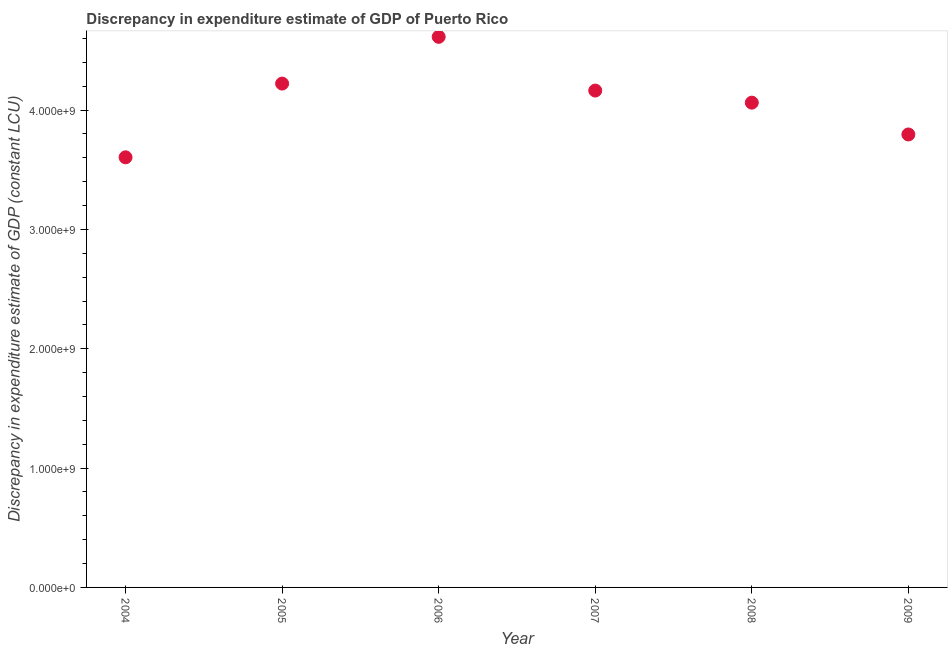What is the discrepancy in expenditure estimate of gdp in 2005?
Ensure brevity in your answer.  4.22e+09. Across all years, what is the maximum discrepancy in expenditure estimate of gdp?
Offer a terse response. 4.61e+09. Across all years, what is the minimum discrepancy in expenditure estimate of gdp?
Offer a terse response. 3.60e+09. In which year was the discrepancy in expenditure estimate of gdp minimum?
Provide a succinct answer. 2004. What is the sum of the discrepancy in expenditure estimate of gdp?
Your response must be concise. 2.45e+1. What is the difference between the discrepancy in expenditure estimate of gdp in 2005 and 2007?
Your response must be concise. 5.86e+07. What is the average discrepancy in expenditure estimate of gdp per year?
Provide a succinct answer. 4.08e+09. What is the median discrepancy in expenditure estimate of gdp?
Provide a succinct answer. 4.11e+09. Do a majority of the years between 2005 and 2009 (inclusive) have discrepancy in expenditure estimate of gdp greater than 400000000 LCU?
Offer a terse response. Yes. What is the ratio of the discrepancy in expenditure estimate of gdp in 2006 to that in 2007?
Provide a short and direct response. 1.11. Is the discrepancy in expenditure estimate of gdp in 2005 less than that in 2007?
Provide a short and direct response. No. Is the difference between the discrepancy in expenditure estimate of gdp in 2004 and 2006 greater than the difference between any two years?
Provide a short and direct response. Yes. What is the difference between the highest and the second highest discrepancy in expenditure estimate of gdp?
Your answer should be compact. 3.92e+08. What is the difference between the highest and the lowest discrepancy in expenditure estimate of gdp?
Your response must be concise. 1.01e+09. In how many years, is the discrepancy in expenditure estimate of gdp greater than the average discrepancy in expenditure estimate of gdp taken over all years?
Provide a succinct answer. 3. How many dotlines are there?
Keep it short and to the point. 1. How many years are there in the graph?
Keep it short and to the point. 6. Are the values on the major ticks of Y-axis written in scientific E-notation?
Ensure brevity in your answer.  Yes. Does the graph contain any zero values?
Your response must be concise. No. What is the title of the graph?
Provide a succinct answer. Discrepancy in expenditure estimate of GDP of Puerto Rico. What is the label or title of the Y-axis?
Your answer should be very brief. Discrepancy in expenditure estimate of GDP (constant LCU). What is the Discrepancy in expenditure estimate of GDP (constant LCU) in 2004?
Provide a succinct answer. 3.60e+09. What is the Discrepancy in expenditure estimate of GDP (constant LCU) in 2005?
Ensure brevity in your answer.  4.22e+09. What is the Discrepancy in expenditure estimate of GDP (constant LCU) in 2006?
Your answer should be compact. 4.61e+09. What is the Discrepancy in expenditure estimate of GDP (constant LCU) in 2007?
Keep it short and to the point. 4.16e+09. What is the Discrepancy in expenditure estimate of GDP (constant LCU) in 2008?
Provide a succinct answer. 4.06e+09. What is the Discrepancy in expenditure estimate of GDP (constant LCU) in 2009?
Provide a short and direct response. 3.80e+09. What is the difference between the Discrepancy in expenditure estimate of GDP (constant LCU) in 2004 and 2005?
Provide a succinct answer. -6.18e+08. What is the difference between the Discrepancy in expenditure estimate of GDP (constant LCU) in 2004 and 2006?
Your answer should be very brief. -1.01e+09. What is the difference between the Discrepancy in expenditure estimate of GDP (constant LCU) in 2004 and 2007?
Your response must be concise. -5.59e+08. What is the difference between the Discrepancy in expenditure estimate of GDP (constant LCU) in 2004 and 2008?
Provide a short and direct response. -4.58e+08. What is the difference between the Discrepancy in expenditure estimate of GDP (constant LCU) in 2004 and 2009?
Offer a terse response. -1.91e+08. What is the difference between the Discrepancy in expenditure estimate of GDP (constant LCU) in 2005 and 2006?
Offer a very short reply. -3.92e+08. What is the difference between the Discrepancy in expenditure estimate of GDP (constant LCU) in 2005 and 2007?
Provide a short and direct response. 5.86e+07. What is the difference between the Discrepancy in expenditure estimate of GDP (constant LCU) in 2005 and 2008?
Provide a short and direct response. 1.60e+08. What is the difference between the Discrepancy in expenditure estimate of GDP (constant LCU) in 2005 and 2009?
Your answer should be very brief. 4.26e+08. What is the difference between the Discrepancy in expenditure estimate of GDP (constant LCU) in 2006 and 2007?
Provide a short and direct response. 4.50e+08. What is the difference between the Discrepancy in expenditure estimate of GDP (constant LCU) in 2006 and 2008?
Your response must be concise. 5.51e+08. What is the difference between the Discrepancy in expenditure estimate of GDP (constant LCU) in 2006 and 2009?
Provide a succinct answer. 8.18e+08. What is the difference between the Discrepancy in expenditure estimate of GDP (constant LCU) in 2007 and 2008?
Ensure brevity in your answer.  1.01e+08. What is the difference between the Discrepancy in expenditure estimate of GDP (constant LCU) in 2007 and 2009?
Give a very brief answer. 3.68e+08. What is the difference between the Discrepancy in expenditure estimate of GDP (constant LCU) in 2008 and 2009?
Your response must be concise. 2.67e+08. What is the ratio of the Discrepancy in expenditure estimate of GDP (constant LCU) in 2004 to that in 2005?
Provide a succinct answer. 0.85. What is the ratio of the Discrepancy in expenditure estimate of GDP (constant LCU) in 2004 to that in 2006?
Provide a succinct answer. 0.78. What is the ratio of the Discrepancy in expenditure estimate of GDP (constant LCU) in 2004 to that in 2007?
Offer a terse response. 0.87. What is the ratio of the Discrepancy in expenditure estimate of GDP (constant LCU) in 2004 to that in 2008?
Your answer should be compact. 0.89. What is the ratio of the Discrepancy in expenditure estimate of GDP (constant LCU) in 2005 to that in 2006?
Offer a terse response. 0.92. What is the ratio of the Discrepancy in expenditure estimate of GDP (constant LCU) in 2005 to that in 2008?
Give a very brief answer. 1.04. What is the ratio of the Discrepancy in expenditure estimate of GDP (constant LCU) in 2005 to that in 2009?
Your answer should be very brief. 1.11. What is the ratio of the Discrepancy in expenditure estimate of GDP (constant LCU) in 2006 to that in 2007?
Offer a terse response. 1.11. What is the ratio of the Discrepancy in expenditure estimate of GDP (constant LCU) in 2006 to that in 2008?
Provide a succinct answer. 1.14. What is the ratio of the Discrepancy in expenditure estimate of GDP (constant LCU) in 2006 to that in 2009?
Ensure brevity in your answer.  1.22. What is the ratio of the Discrepancy in expenditure estimate of GDP (constant LCU) in 2007 to that in 2009?
Offer a very short reply. 1.1. What is the ratio of the Discrepancy in expenditure estimate of GDP (constant LCU) in 2008 to that in 2009?
Offer a terse response. 1.07. 